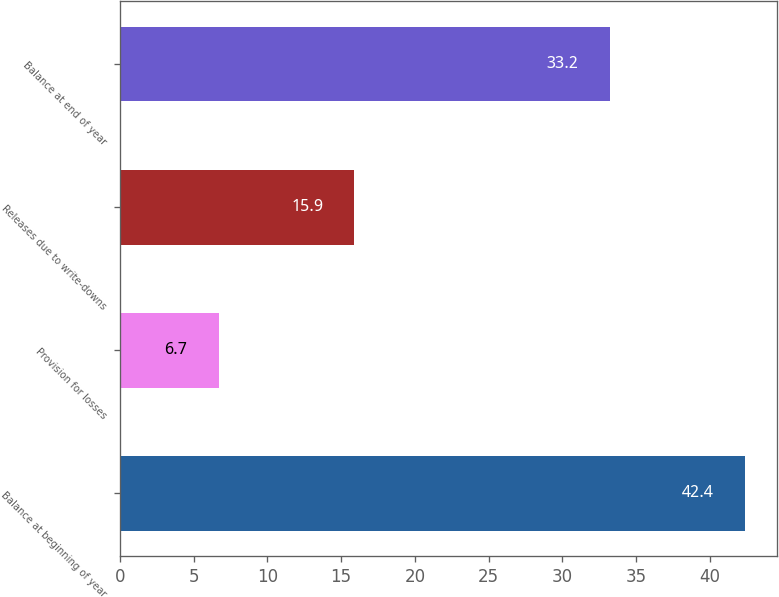<chart> <loc_0><loc_0><loc_500><loc_500><bar_chart><fcel>Balance at beginning of year<fcel>Provision for losses<fcel>Releases due to write-downs<fcel>Balance at end of year<nl><fcel>42.4<fcel>6.7<fcel>15.9<fcel>33.2<nl></chart> 